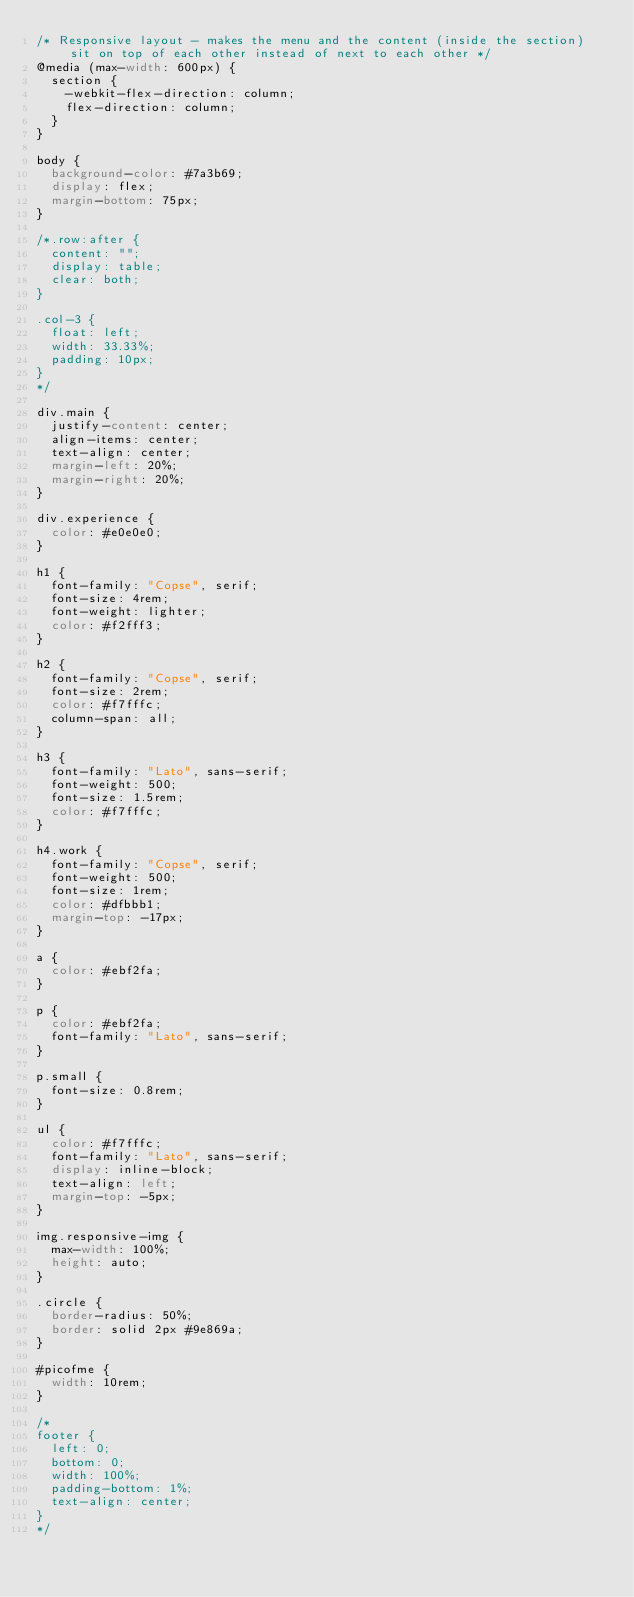Convert code to text. <code><loc_0><loc_0><loc_500><loc_500><_CSS_>/* Responsive layout - makes the menu and the content (inside the section) sit on top of each other instead of next to each other */
@media (max-width: 600px) {
  section {
    -webkit-flex-direction: column;
    flex-direction: column;
  }
}

body {
  background-color: #7a3b69;
  display: flex;
  margin-bottom: 75px;
}

/*.row:after {
  content: "";
  display: table;
  clear: both;
}

.col-3 {
  float: left;
  width: 33.33%;
  padding: 10px;
}
*/

div.main {
  justify-content: center;
  align-items: center;
  text-align: center;
  margin-left: 20%;
  margin-right: 20%;
}

div.experience {
  color: #e0e0e0;
}

h1 {
  font-family: "Copse", serif;
  font-size: 4rem;
  font-weight: lighter;
  color: #f2fff3;
}

h2 {
  font-family: "Copse", serif;
  font-size: 2rem;
  color: #f7fffc;
  column-span: all;
}

h3 {
  font-family: "Lato", sans-serif;
  font-weight: 500;
  font-size: 1.5rem;
  color: #f7fffc;
}

h4.work {
  font-family: "Copse", serif;
  font-weight: 500;
  font-size: 1rem;
  color: #dfbbb1;
  margin-top: -17px;
}

a {
  color: #ebf2fa;
}

p {
  color: #ebf2fa;
  font-family: "Lato", sans-serif;
}

p.small {
  font-size: 0.8rem;
}

ul {
  color: #f7fffc;
  font-family: "Lato", sans-serif;
  display: inline-block;
  text-align: left;
  margin-top: -5px;
}

img.responsive-img {
  max-width: 100%;
  height: auto;
}

.circle {
  border-radius: 50%;
  border: solid 2px #9e869a;
}

#picofme {
  width: 10rem;
}

/*
footer {
  left: 0;
  bottom: 0;
  width: 100%;
  padding-bottom: 1%;
  text-align: center;
}
*/
</code> 